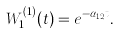Convert formula to latex. <formula><loc_0><loc_0><loc_500><loc_500>W _ { 1 } ^ { ( 1 ) } ( t ) = e ^ { - \alpha _ { 1 2 } t } .</formula> 